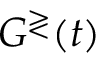<formula> <loc_0><loc_0><loc_500><loc_500>G ^ { \gtrless } ( t )</formula> 